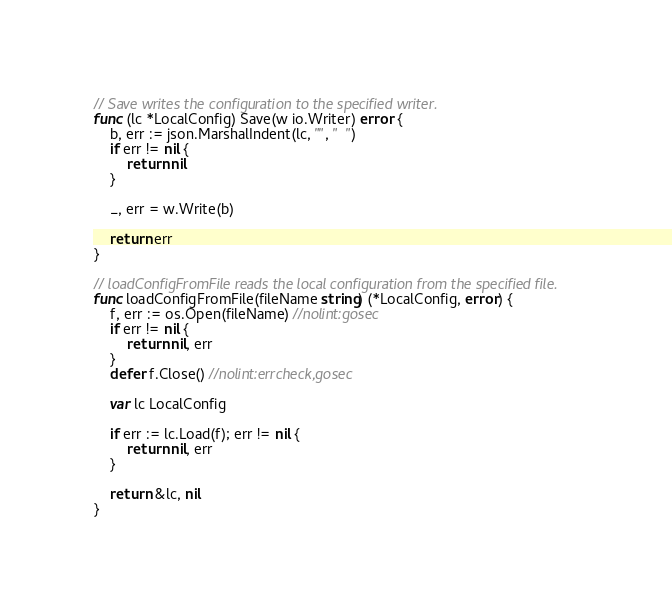<code> <loc_0><loc_0><loc_500><loc_500><_Go_>
// Save writes the configuration to the specified writer.
func (lc *LocalConfig) Save(w io.Writer) error {
	b, err := json.MarshalIndent(lc, "", "  ")
	if err != nil {
		return nil
	}

	_, err = w.Write(b)

	return err
}

// loadConfigFromFile reads the local configuration from the specified file.
func loadConfigFromFile(fileName string) (*LocalConfig, error) {
	f, err := os.Open(fileName) //nolint:gosec
	if err != nil {
		return nil, err
	}
	defer f.Close() //nolint:errcheck,gosec

	var lc LocalConfig

	if err := lc.Load(f); err != nil {
		return nil, err
	}

	return &lc, nil
}
</code> 